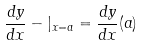<formula> <loc_0><loc_0><loc_500><loc_500>\frac { d y } { d x } - | _ { x = a } = \frac { d y } { d x } ( a )</formula> 